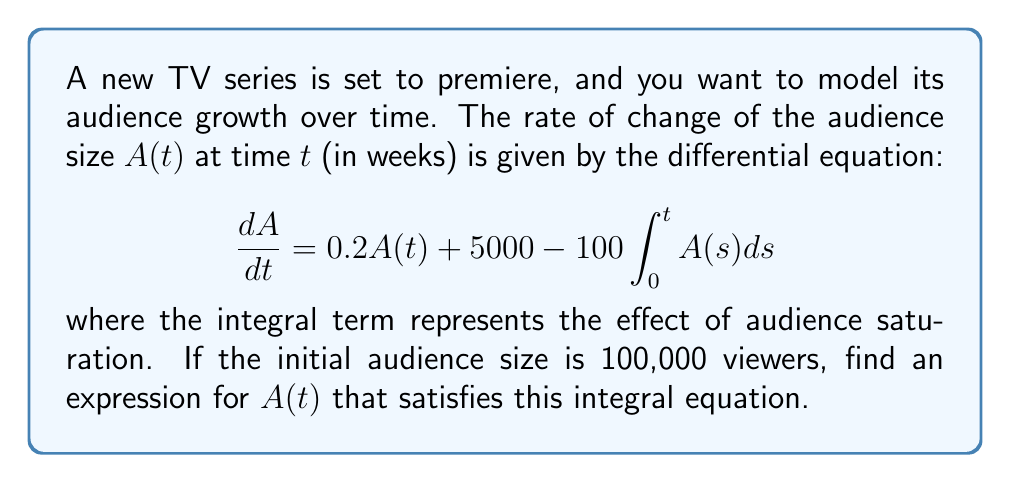Can you answer this question? To solve this integral equation, we'll follow these steps:

1) First, let's differentiate both sides of the equation with respect to t:

   $$\frac{d^2A}{dt^2} = 0.2\frac{dA}{dt} - 100A(t)$$

2) This is now a second-order linear differential equation. We can solve it using the characteristic equation method.

3) The characteristic equation is:

   $$r^2 - 0.2r + 100 = 0$$

4) Solving this quadratic equation:

   $$r = \frac{0.2 \pm \sqrt{0.04 - 400}}{2} = 0.1 \pm 10i$$

5) Therefore, the general solution is:

   $$A(t) = e^{0.1t}(C_1\cos(10t) + C_2\sin(10t)) + K$$

   where K is a particular solution of the non-homogeneous equation.

6) To find K, we substitute this general solution back into the original equation:

   $$0.1e^{0.1t}(C_1\cos(10t) + C_2\sin(10t)) + 10e^{0.1t}(-C_1\sin(10t) + C_2\cos(10t)) = 0.2K + 5000 - 100Kt$$

7) For this to be true for all t, we must have:

   $$0.2K + 5000 - 100Kt = 0$$
   $$K = 50000$$

8) Now we have:

   $$A(t) = e^{0.1t}(C_1\cos(10t) + C_2\sin(10t)) + 50000$$

9) To find C_1 and C_2, we use the initial condition A(0) = 100,000:

   $$100000 = C_1 + 50000$$
   $$C_1 = 50000$$

10) And we need one more condition. We can get this from the original equation at t = 0:

    $$\frac{dA}{dt}(0) = 0.2(100000) + 5000 = 25000$$

11) This gives us:

    $$25000 = 0.1(50000) + 10C_2$$
    $$C_2 = 2000$$

Therefore, the final solution is:

$$A(t) = 50000e^{0.1t}(\cos(10t) + 0.04\sin(10t)) + 50000$$
Answer: $A(t) = 50000e^{0.1t}(\cos(10t) + 0.04\sin(10t)) + 50000$ 